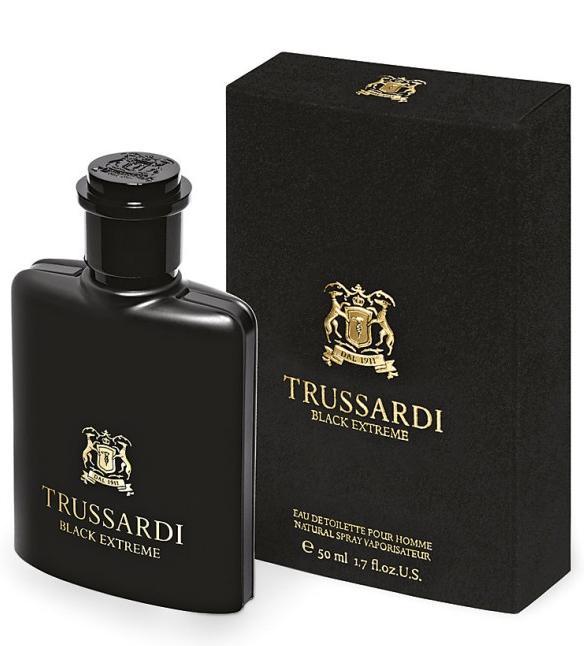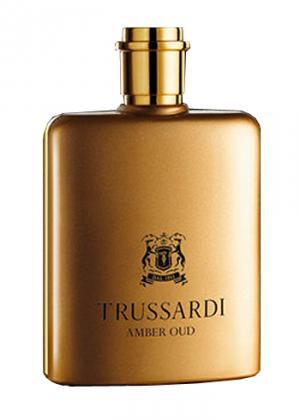The first image is the image on the left, the second image is the image on the right. Analyze the images presented: Is the assertion "Each image includes exactly two objects, and one image features an upright angled black bottle to the left of an upright angled white bottle." valid? Answer yes or no. No. 